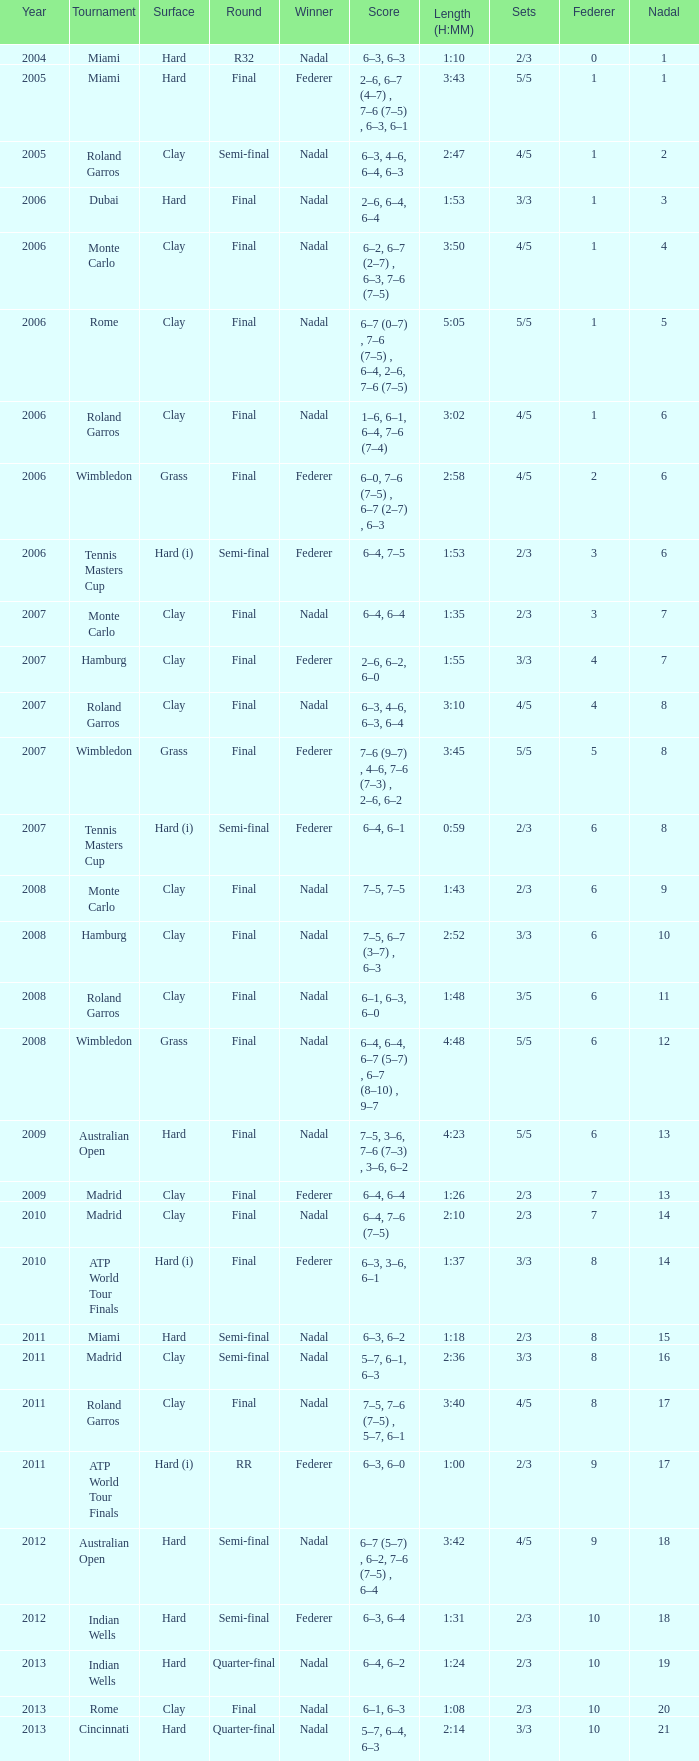What was the outcome for nadal in the final round in miami? 1.0. 